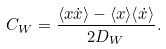<formula> <loc_0><loc_0><loc_500><loc_500>C _ { W } = \frac { \langle x \dot { x } \rangle - \langle x \rangle \langle \dot { x } \rangle } { 2 D _ { W } } .</formula> 